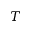Convert formula to latex. <formula><loc_0><loc_0><loc_500><loc_500>T</formula> 